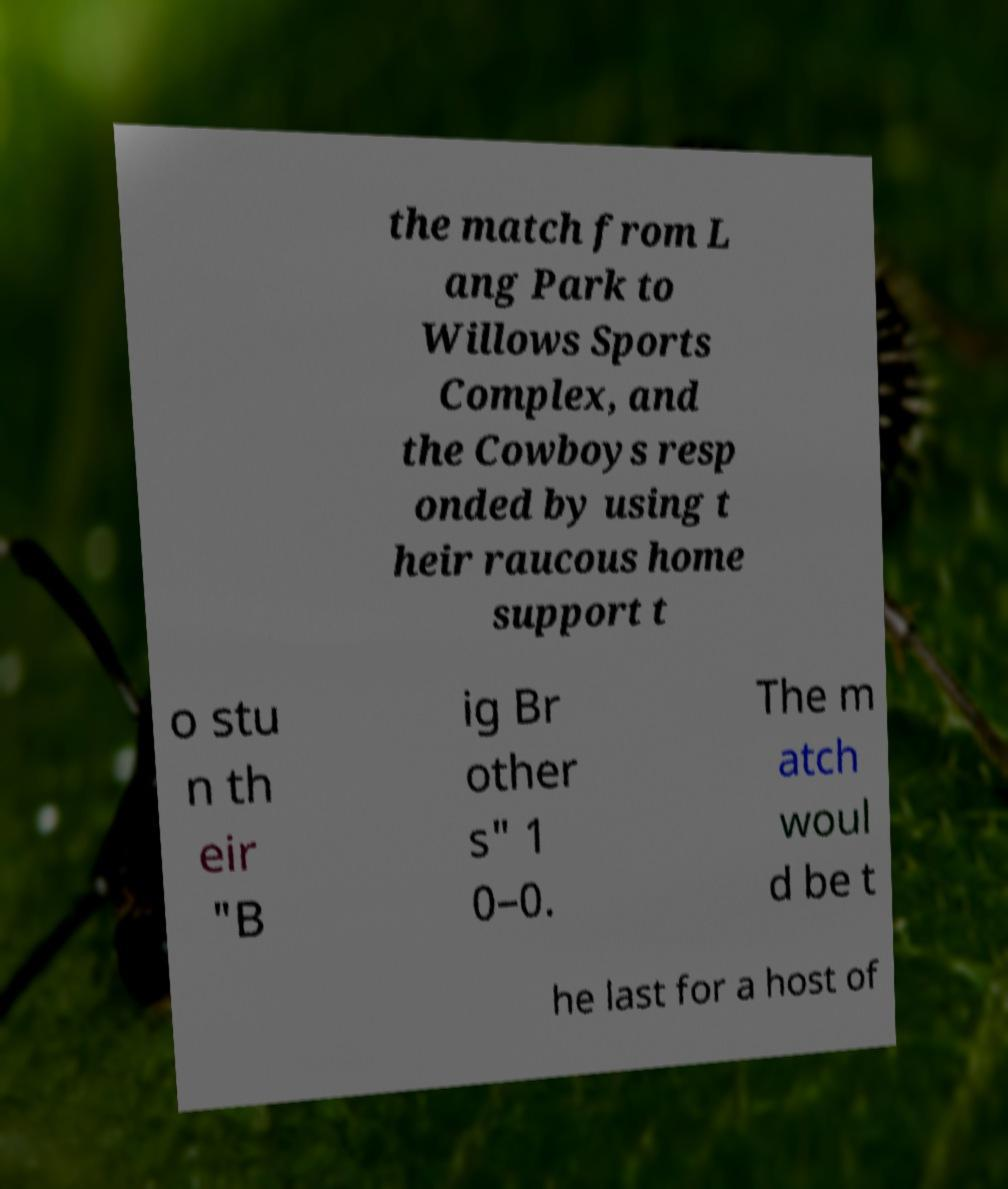Can you accurately transcribe the text from the provided image for me? the match from L ang Park to Willows Sports Complex, and the Cowboys resp onded by using t heir raucous home support t o stu n th eir "B ig Br other s" 1 0–0. The m atch woul d be t he last for a host of 